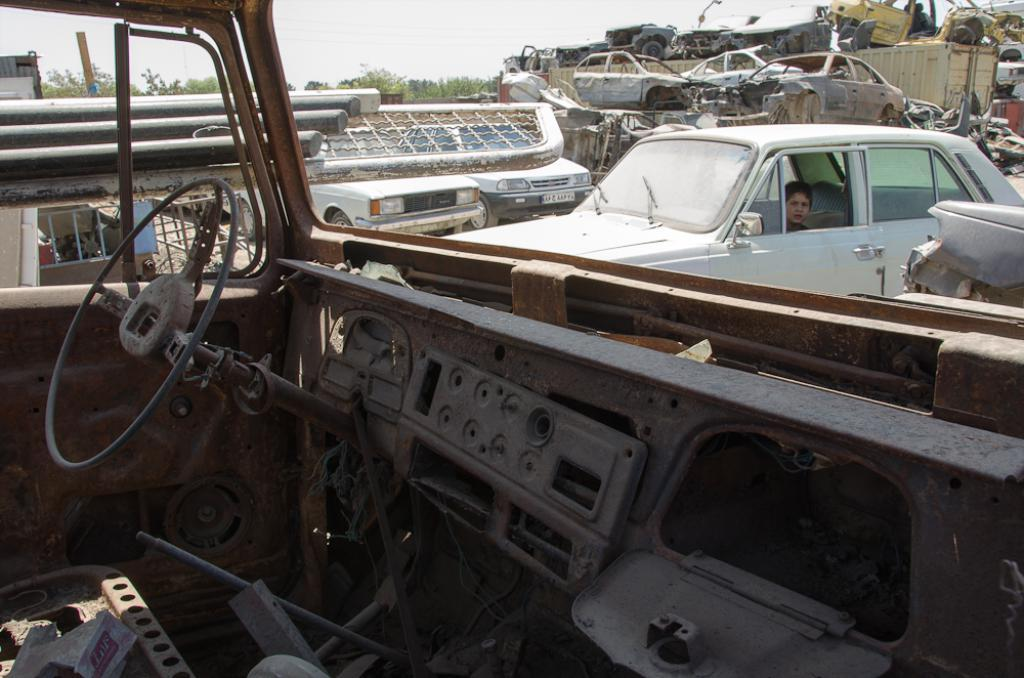What is located in the front of the image? There is scrap in the front of the image. What is the main subject in the center of the image? There is a car in the center of the image. Who is inside the car? A boy is sitting in the car. What can be seen in the background of the image? There are cars, scraps, and trees in the background of the image. What type of song is being sung by the boy in the car? There is no indication in the image that the boy is singing a song, so it cannot be determined from the picture. What is the boy using to fuel the car? The image does not show the boy using any fuel for the car, and there is no mention of coal in the provided facts. 